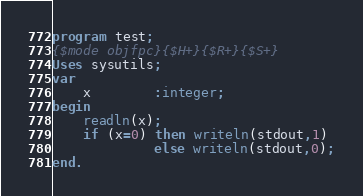<code> <loc_0><loc_0><loc_500><loc_500><_Pascal_>program test;
{$mode objfpc}{$H+}{$R+}{$S+}
Uses sysutils;
var
	x		:integer;
begin
    readln(x);
    if (x=0) then writeln(stdout,1)
             else writeln(stdout,0);
end.</code> 